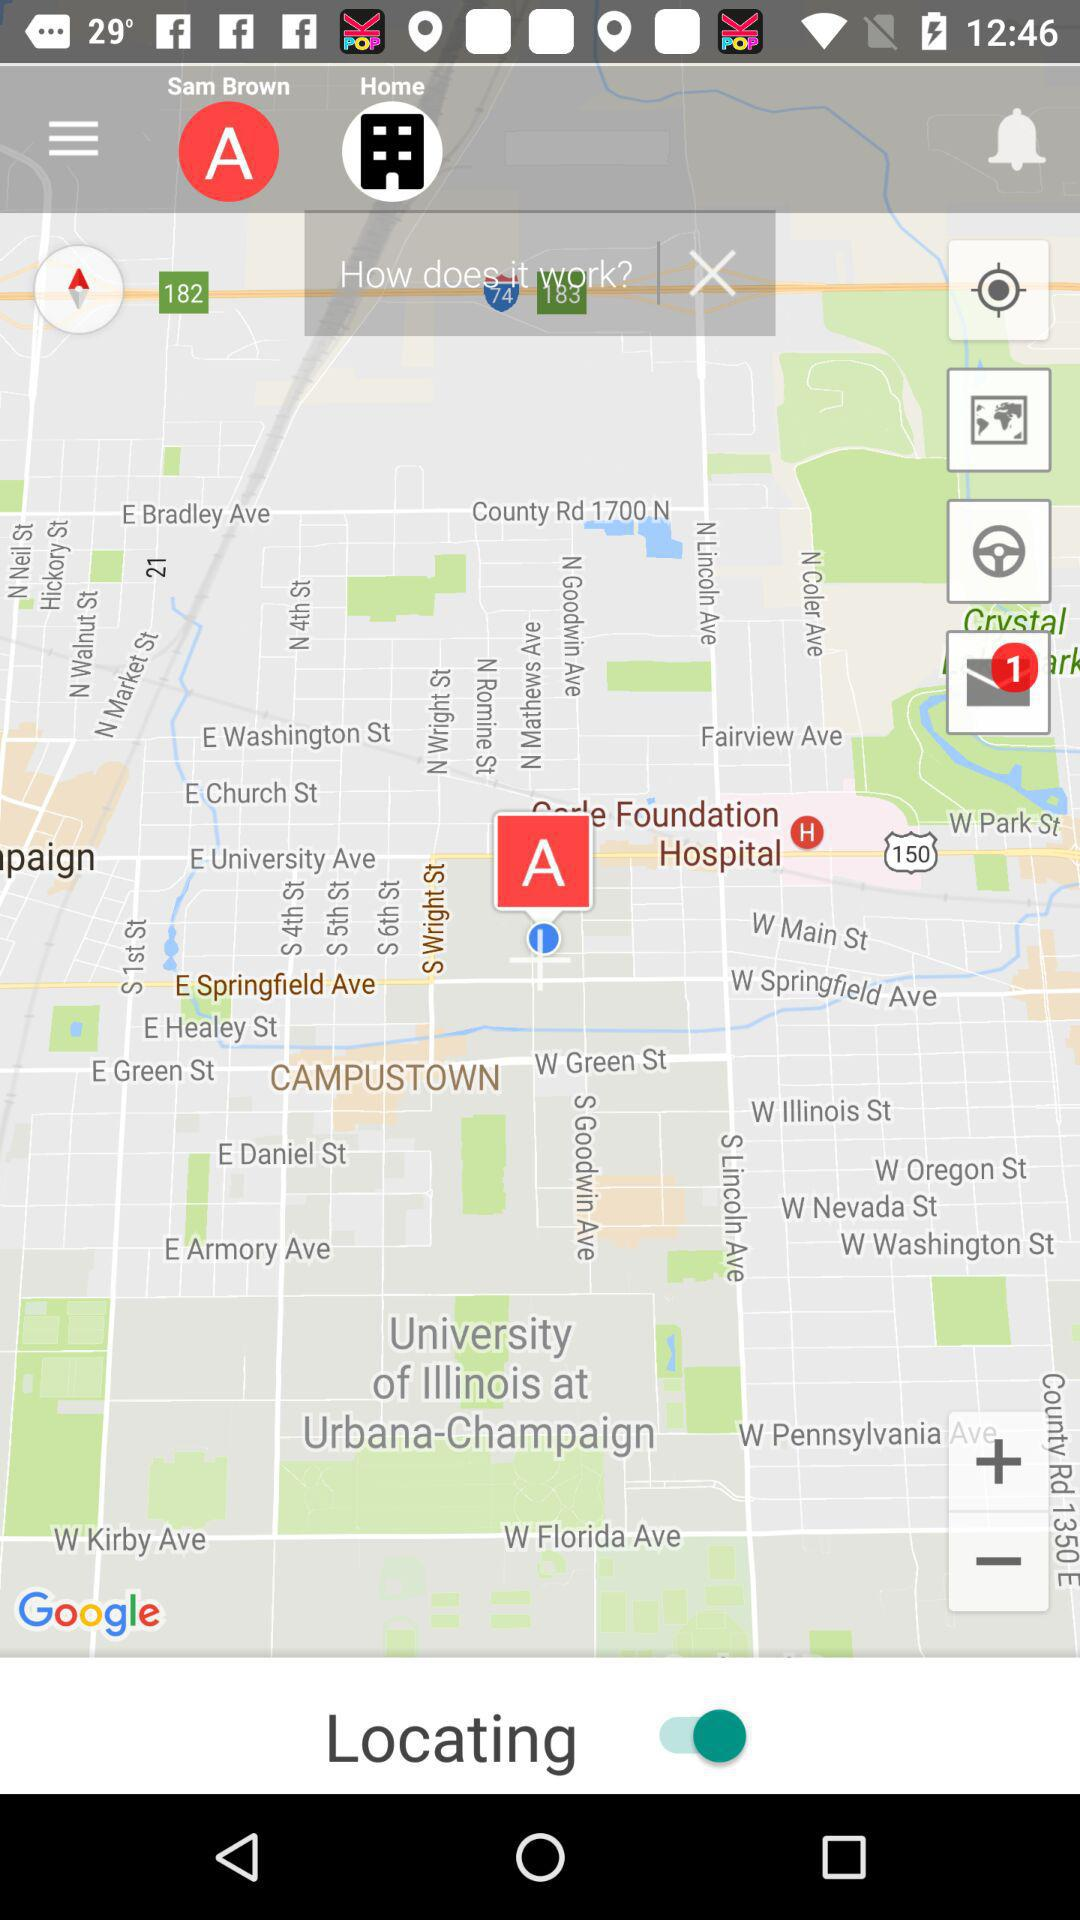How many unread notifications are there? There is 1 unread notification. 